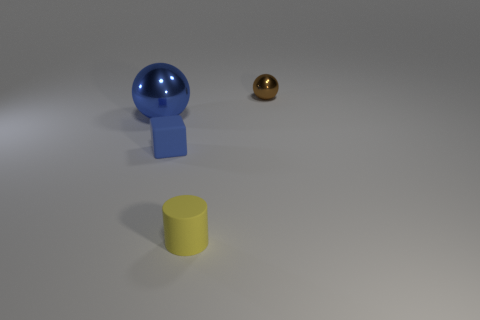Add 3 big blue spheres. How many objects exist? 7 Subtract all blocks. How many objects are left? 3 Add 2 large shiny things. How many large shiny things exist? 3 Subtract 0 red cylinders. How many objects are left? 4 Subtract all big rubber balls. Subtract all blocks. How many objects are left? 3 Add 2 large blue shiny objects. How many large blue shiny objects are left? 3 